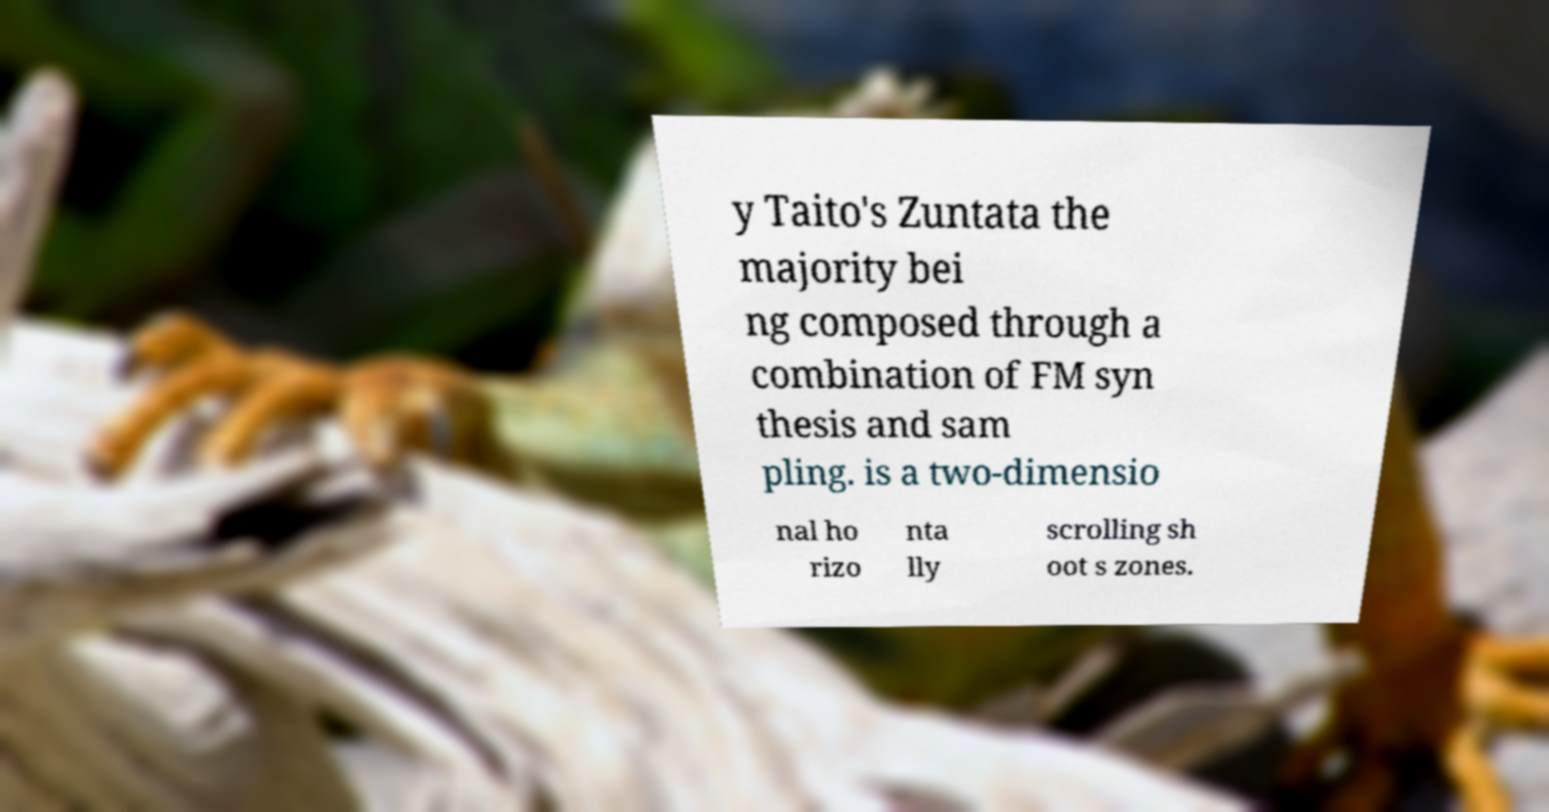What messages or text are displayed in this image? I need them in a readable, typed format. y Taito's Zuntata the majority bei ng composed through a combination of FM syn thesis and sam pling. is a two-dimensio nal ho rizo nta lly scrolling sh oot s zones. 